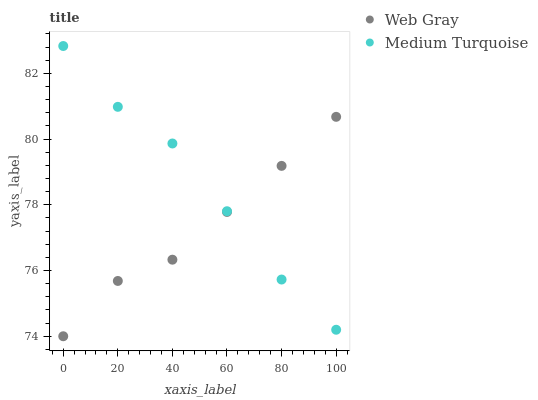Does Web Gray have the minimum area under the curve?
Answer yes or no. Yes. Does Medium Turquoise have the maximum area under the curve?
Answer yes or no. Yes. Does Medium Turquoise have the minimum area under the curve?
Answer yes or no. No. Is Web Gray the smoothest?
Answer yes or no. Yes. Is Medium Turquoise the roughest?
Answer yes or no. Yes. Is Medium Turquoise the smoothest?
Answer yes or no. No. Does Web Gray have the lowest value?
Answer yes or no. Yes. Does Medium Turquoise have the lowest value?
Answer yes or no. No. Does Medium Turquoise have the highest value?
Answer yes or no. Yes. Does Medium Turquoise intersect Web Gray?
Answer yes or no. Yes. Is Medium Turquoise less than Web Gray?
Answer yes or no. No. Is Medium Turquoise greater than Web Gray?
Answer yes or no. No. 